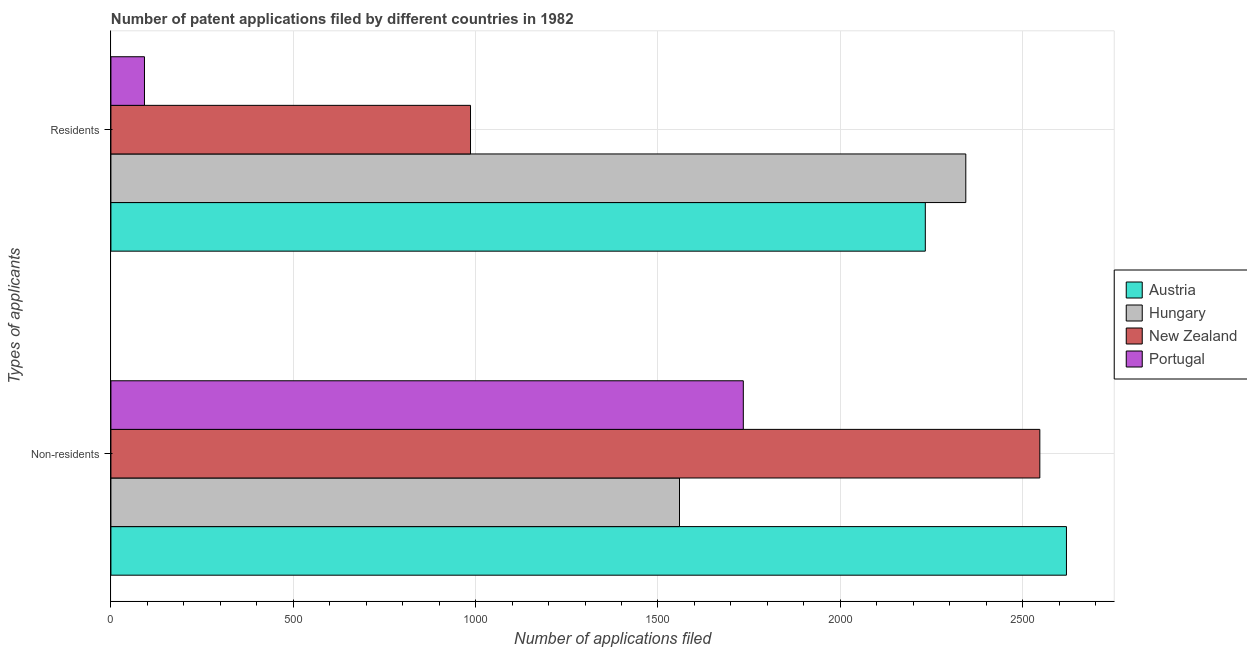How many different coloured bars are there?
Make the answer very short. 4. How many groups of bars are there?
Ensure brevity in your answer.  2. Are the number of bars per tick equal to the number of legend labels?
Keep it short and to the point. Yes. How many bars are there on the 1st tick from the bottom?
Make the answer very short. 4. What is the label of the 2nd group of bars from the top?
Your answer should be very brief. Non-residents. What is the number of patent applications by non residents in Portugal?
Keep it short and to the point. 1734. Across all countries, what is the maximum number of patent applications by residents?
Provide a short and direct response. 2344. Across all countries, what is the minimum number of patent applications by residents?
Your answer should be compact. 92. In which country was the number of patent applications by residents maximum?
Your response must be concise. Hungary. In which country was the number of patent applications by non residents minimum?
Offer a very short reply. Hungary. What is the total number of patent applications by residents in the graph?
Give a very brief answer. 5655. What is the difference between the number of patent applications by non residents in Austria and that in New Zealand?
Give a very brief answer. 73. What is the difference between the number of patent applications by residents in Portugal and the number of patent applications by non residents in Austria?
Your answer should be compact. -2528. What is the average number of patent applications by non residents per country?
Keep it short and to the point. 2115. What is the difference between the number of patent applications by non residents and number of patent applications by residents in New Zealand?
Offer a very short reply. 1561. What is the ratio of the number of patent applications by non residents in Austria to that in Hungary?
Keep it short and to the point. 1.68. What does the 2nd bar from the top in Non-residents represents?
Give a very brief answer. New Zealand. What does the 3rd bar from the bottom in Non-residents represents?
Offer a very short reply. New Zealand. How many bars are there?
Provide a succinct answer. 8. How many countries are there in the graph?
Provide a short and direct response. 4. What is the difference between two consecutive major ticks on the X-axis?
Provide a short and direct response. 500. Are the values on the major ticks of X-axis written in scientific E-notation?
Make the answer very short. No. Does the graph contain any zero values?
Keep it short and to the point. No. How many legend labels are there?
Ensure brevity in your answer.  4. How are the legend labels stacked?
Ensure brevity in your answer.  Vertical. What is the title of the graph?
Offer a terse response. Number of patent applications filed by different countries in 1982. What is the label or title of the X-axis?
Make the answer very short. Number of applications filed. What is the label or title of the Y-axis?
Your answer should be very brief. Types of applicants. What is the Number of applications filed of Austria in Non-residents?
Give a very brief answer. 2620. What is the Number of applications filed of Hungary in Non-residents?
Offer a very short reply. 1559. What is the Number of applications filed of New Zealand in Non-residents?
Provide a short and direct response. 2547. What is the Number of applications filed in Portugal in Non-residents?
Your answer should be compact. 1734. What is the Number of applications filed in Austria in Residents?
Your response must be concise. 2233. What is the Number of applications filed of Hungary in Residents?
Provide a short and direct response. 2344. What is the Number of applications filed of New Zealand in Residents?
Give a very brief answer. 986. What is the Number of applications filed of Portugal in Residents?
Keep it short and to the point. 92. Across all Types of applicants, what is the maximum Number of applications filed of Austria?
Make the answer very short. 2620. Across all Types of applicants, what is the maximum Number of applications filed of Hungary?
Offer a terse response. 2344. Across all Types of applicants, what is the maximum Number of applications filed in New Zealand?
Give a very brief answer. 2547. Across all Types of applicants, what is the maximum Number of applications filed of Portugal?
Keep it short and to the point. 1734. Across all Types of applicants, what is the minimum Number of applications filed of Austria?
Give a very brief answer. 2233. Across all Types of applicants, what is the minimum Number of applications filed in Hungary?
Your response must be concise. 1559. Across all Types of applicants, what is the minimum Number of applications filed in New Zealand?
Offer a terse response. 986. Across all Types of applicants, what is the minimum Number of applications filed in Portugal?
Offer a terse response. 92. What is the total Number of applications filed in Austria in the graph?
Ensure brevity in your answer.  4853. What is the total Number of applications filed in Hungary in the graph?
Your answer should be compact. 3903. What is the total Number of applications filed in New Zealand in the graph?
Offer a terse response. 3533. What is the total Number of applications filed in Portugal in the graph?
Provide a succinct answer. 1826. What is the difference between the Number of applications filed of Austria in Non-residents and that in Residents?
Your answer should be very brief. 387. What is the difference between the Number of applications filed in Hungary in Non-residents and that in Residents?
Provide a succinct answer. -785. What is the difference between the Number of applications filed of New Zealand in Non-residents and that in Residents?
Provide a succinct answer. 1561. What is the difference between the Number of applications filed in Portugal in Non-residents and that in Residents?
Provide a succinct answer. 1642. What is the difference between the Number of applications filed of Austria in Non-residents and the Number of applications filed of Hungary in Residents?
Provide a succinct answer. 276. What is the difference between the Number of applications filed in Austria in Non-residents and the Number of applications filed in New Zealand in Residents?
Your answer should be very brief. 1634. What is the difference between the Number of applications filed of Austria in Non-residents and the Number of applications filed of Portugal in Residents?
Give a very brief answer. 2528. What is the difference between the Number of applications filed of Hungary in Non-residents and the Number of applications filed of New Zealand in Residents?
Make the answer very short. 573. What is the difference between the Number of applications filed of Hungary in Non-residents and the Number of applications filed of Portugal in Residents?
Give a very brief answer. 1467. What is the difference between the Number of applications filed in New Zealand in Non-residents and the Number of applications filed in Portugal in Residents?
Your answer should be compact. 2455. What is the average Number of applications filed in Austria per Types of applicants?
Provide a succinct answer. 2426.5. What is the average Number of applications filed of Hungary per Types of applicants?
Make the answer very short. 1951.5. What is the average Number of applications filed of New Zealand per Types of applicants?
Ensure brevity in your answer.  1766.5. What is the average Number of applications filed in Portugal per Types of applicants?
Your answer should be very brief. 913. What is the difference between the Number of applications filed of Austria and Number of applications filed of Hungary in Non-residents?
Give a very brief answer. 1061. What is the difference between the Number of applications filed of Austria and Number of applications filed of New Zealand in Non-residents?
Offer a terse response. 73. What is the difference between the Number of applications filed in Austria and Number of applications filed in Portugal in Non-residents?
Offer a terse response. 886. What is the difference between the Number of applications filed in Hungary and Number of applications filed in New Zealand in Non-residents?
Keep it short and to the point. -988. What is the difference between the Number of applications filed of Hungary and Number of applications filed of Portugal in Non-residents?
Give a very brief answer. -175. What is the difference between the Number of applications filed of New Zealand and Number of applications filed of Portugal in Non-residents?
Provide a succinct answer. 813. What is the difference between the Number of applications filed of Austria and Number of applications filed of Hungary in Residents?
Make the answer very short. -111. What is the difference between the Number of applications filed of Austria and Number of applications filed of New Zealand in Residents?
Make the answer very short. 1247. What is the difference between the Number of applications filed in Austria and Number of applications filed in Portugal in Residents?
Ensure brevity in your answer.  2141. What is the difference between the Number of applications filed of Hungary and Number of applications filed of New Zealand in Residents?
Keep it short and to the point. 1358. What is the difference between the Number of applications filed of Hungary and Number of applications filed of Portugal in Residents?
Your response must be concise. 2252. What is the difference between the Number of applications filed of New Zealand and Number of applications filed of Portugal in Residents?
Give a very brief answer. 894. What is the ratio of the Number of applications filed in Austria in Non-residents to that in Residents?
Provide a succinct answer. 1.17. What is the ratio of the Number of applications filed in Hungary in Non-residents to that in Residents?
Ensure brevity in your answer.  0.67. What is the ratio of the Number of applications filed in New Zealand in Non-residents to that in Residents?
Provide a short and direct response. 2.58. What is the ratio of the Number of applications filed of Portugal in Non-residents to that in Residents?
Your answer should be very brief. 18.85. What is the difference between the highest and the second highest Number of applications filed in Austria?
Keep it short and to the point. 387. What is the difference between the highest and the second highest Number of applications filed in Hungary?
Ensure brevity in your answer.  785. What is the difference between the highest and the second highest Number of applications filed of New Zealand?
Your response must be concise. 1561. What is the difference between the highest and the second highest Number of applications filed of Portugal?
Your answer should be compact. 1642. What is the difference between the highest and the lowest Number of applications filed in Austria?
Your answer should be very brief. 387. What is the difference between the highest and the lowest Number of applications filed in Hungary?
Give a very brief answer. 785. What is the difference between the highest and the lowest Number of applications filed of New Zealand?
Your answer should be very brief. 1561. What is the difference between the highest and the lowest Number of applications filed in Portugal?
Provide a short and direct response. 1642. 